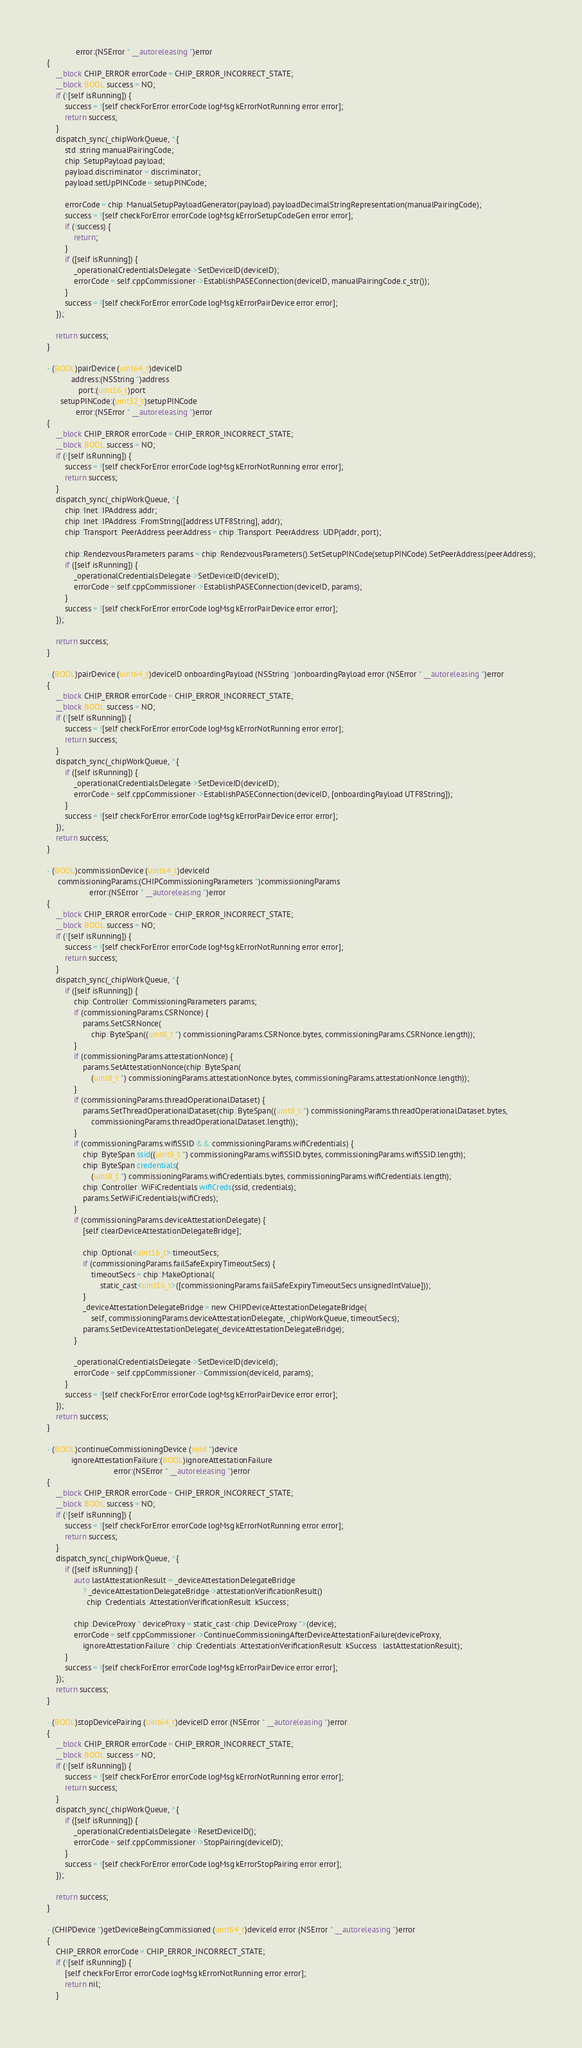Convert code to text. <code><loc_0><loc_0><loc_500><loc_500><_ObjectiveC_>             error:(NSError * __autoreleasing *)error
{
    __block CHIP_ERROR errorCode = CHIP_ERROR_INCORRECT_STATE;
    __block BOOL success = NO;
    if (![self isRunning]) {
        success = ![self checkForError:errorCode logMsg:kErrorNotRunning error:error];
        return success;
    }
    dispatch_sync(_chipWorkQueue, ^{
        std::string manualPairingCode;
        chip::SetupPayload payload;
        payload.discriminator = discriminator;
        payload.setUpPINCode = setupPINCode;

        errorCode = chip::ManualSetupPayloadGenerator(payload).payloadDecimalStringRepresentation(manualPairingCode);
        success = ![self checkForError:errorCode logMsg:kErrorSetupCodeGen error:error];
        if (!success) {
            return;
        }
        if ([self isRunning]) {
            _operationalCredentialsDelegate->SetDeviceID(deviceID);
            errorCode = self.cppCommissioner->EstablishPASEConnection(deviceID, manualPairingCode.c_str());
        }
        success = ![self checkForError:errorCode logMsg:kErrorPairDevice error:error];
    });

    return success;
}

- (BOOL)pairDevice:(uint64_t)deviceID
           address:(NSString *)address
              port:(uint16_t)port
      setupPINCode:(uint32_t)setupPINCode
             error:(NSError * __autoreleasing *)error
{
    __block CHIP_ERROR errorCode = CHIP_ERROR_INCORRECT_STATE;
    __block BOOL success = NO;
    if (![self isRunning]) {
        success = ![self checkForError:errorCode logMsg:kErrorNotRunning error:error];
        return success;
    }
    dispatch_sync(_chipWorkQueue, ^{
        chip::Inet::IPAddress addr;
        chip::Inet::IPAddress::FromString([address UTF8String], addr);
        chip::Transport::PeerAddress peerAddress = chip::Transport::PeerAddress::UDP(addr, port);

        chip::RendezvousParameters params = chip::RendezvousParameters().SetSetupPINCode(setupPINCode).SetPeerAddress(peerAddress);
        if ([self isRunning]) {
            _operationalCredentialsDelegate->SetDeviceID(deviceID);
            errorCode = self.cppCommissioner->EstablishPASEConnection(deviceID, params);
        }
        success = ![self checkForError:errorCode logMsg:kErrorPairDevice error:error];
    });

    return success;
}

- (BOOL)pairDevice:(uint64_t)deviceID onboardingPayload:(NSString *)onboardingPayload error:(NSError * __autoreleasing *)error
{
    __block CHIP_ERROR errorCode = CHIP_ERROR_INCORRECT_STATE;
    __block BOOL success = NO;
    if (![self isRunning]) {
        success = ![self checkForError:errorCode logMsg:kErrorNotRunning error:error];
        return success;
    }
    dispatch_sync(_chipWorkQueue, ^{
        if ([self isRunning]) {
            _operationalCredentialsDelegate->SetDeviceID(deviceID);
            errorCode = self.cppCommissioner->EstablishPASEConnection(deviceID, [onboardingPayload UTF8String]);
        }
        success = ![self checkForError:errorCode logMsg:kErrorPairDevice error:error];
    });
    return success;
}

- (BOOL)commissionDevice:(uint64_t)deviceId
     commissioningParams:(CHIPCommissioningParameters *)commissioningParams
                   error:(NSError * __autoreleasing *)error
{
    __block CHIP_ERROR errorCode = CHIP_ERROR_INCORRECT_STATE;
    __block BOOL success = NO;
    if (![self isRunning]) {
        success = ![self checkForError:errorCode logMsg:kErrorNotRunning error:error];
        return success;
    }
    dispatch_sync(_chipWorkQueue, ^{
        if ([self isRunning]) {
            chip::Controller::CommissioningParameters params;
            if (commissioningParams.CSRNonce) {
                params.SetCSRNonce(
                    chip::ByteSpan((uint8_t *) commissioningParams.CSRNonce.bytes, commissioningParams.CSRNonce.length));
            }
            if (commissioningParams.attestationNonce) {
                params.SetAttestationNonce(chip::ByteSpan(
                    (uint8_t *) commissioningParams.attestationNonce.bytes, commissioningParams.attestationNonce.length));
            }
            if (commissioningParams.threadOperationalDataset) {
                params.SetThreadOperationalDataset(chip::ByteSpan((uint8_t *) commissioningParams.threadOperationalDataset.bytes,
                    commissioningParams.threadOperationalDataset.length));
            }
            if (commissioningParams.wifiSSID && commissioningParams.wifiCredentials) {
                chip::ByteSpan ssid((uint8_t *) commissioningParams.wifiSSID.bytes, commissioningParams.wifiSSID.length);
                chip::ByteSpan credentials(
                    (uint8_t *) commissioningParams.wifiCredentials.bytes, commissioningParams.wifiCredentials.length);
                chip::Controller::WiFiCredentials wifiCreds(ssid, credentials);
                params.SetWiFiCredentials(wifiCreds);
            }
            if (commissioningParams.deviceAttestationDelegate) {
                [self clearDeviceAttestationDelegateBridge];

                chip::Optional<uint16_t> timeoutSecs;
                if (commissioningParams.failSafeExpiryTimeoutSecs) {
                    timeoutSecs = chip::MakeOptional(
                        static_cast<uint16_t>([commissioningParams.failSafeExpiryTimeoutSecs unsignedIntValue]));
                }
                _deviceAttestationDelegateBridge = new CHIPDeviceAttestationDelegateBridge(
                    self, commissioningParams.deviceAttestationDelegate, _chipWorkQueue, timeoutSecs);
                params.SetDeviceAttestationDelegate(_deviceAttestationDelegateBridge);
            }

            _operationalCredentialsDelegate->SetDeviceID(deviceId);
            errorCode = self.cppCommissioner->Commission(deviceId, params);
        }
        success = ![self checkForError:errorCode logMsg:kErrorPairDevice error:error];
    });
    return success;
}

- (BOOL)continueCommissioningDevice:(void *)device
           ignoreAttestationFailure:(BOOL)ignoreAttestationFailure
                              error:(NSError * __autoreleasing *)error
{
    __block CHIP_ERROR errorCode = CHIP_ERROR_INCORRECT_STATE;
    __block BOOL success = NO;
    if (![self isRunning]) {
        success = ![self checkForError:errorCode logMsg:kErrorNotRunning error:error];
        return success;
    }
    dispatch_sync(_chipWorkQueue, ^{
        if ([self isRunning]) {
            auto lastAttestationResult = _deviceAttestationDelegateBridge
                ? _deviceAttestationDelegateBridge->attestationVerificationResult()
                : chip::Credentials::AttestationVerificationResult::kSuccess;

            chip::DeviceProxy * deviceProxy = static_cast<chip::DeviceProxy *>(device);
            errorCode = self.cppCommissioner->ContinueCommissioningAfterDeviceAttestationFailure(deviceProxy,
                ignoreAttestationFailure ? chip::Credentials::AttestationVerificationResult::kSuccess : lastAttestationResult);
        }
        success = ![self checkForError:errorCode logMsg:kErrorPairDevice error:error];
    });
    return success;
}

- (BOOL)stopDevicePairing:(uint64_t)deviceID error:(NSError * __autoreleasing *)error
{
    __block CHIP_ERROR errorCode = CHIP_ERROR_INCORRECT_STATE;
    __block BOOL success = NO;
    if (![self isRunning]) {
        success = ![self checkForError:errorCode logMsg:kErrorNotRunning error:error];
        return success;
    }
    dispatch_sync(_chipWorkQueue, ^{
        if ([self isRunning]) {
            _operationalCredentialsDelegate->ResetDeviceID();
            errorCode = self.cppCommissioner->StopPairing(deviceID);
        }
        success = ![self checkForError:errorCode logMsg:kErrorStopPairing error:error];
    });

    return success;
}

- (CHIPDevice *)getDeviceBeingCommissioned:(uint64_t)deviceId error:(NSError * __autoreleasing *)error
{
    CHIP_ERROR errorCode = CHIP_ERROR_INCORRECT_STATE;
    if (![self isRunning]) {
        [self checkForError:errorCode logMsg:kErrorNotRunning error:error];
        return nil;
    }
</code> 